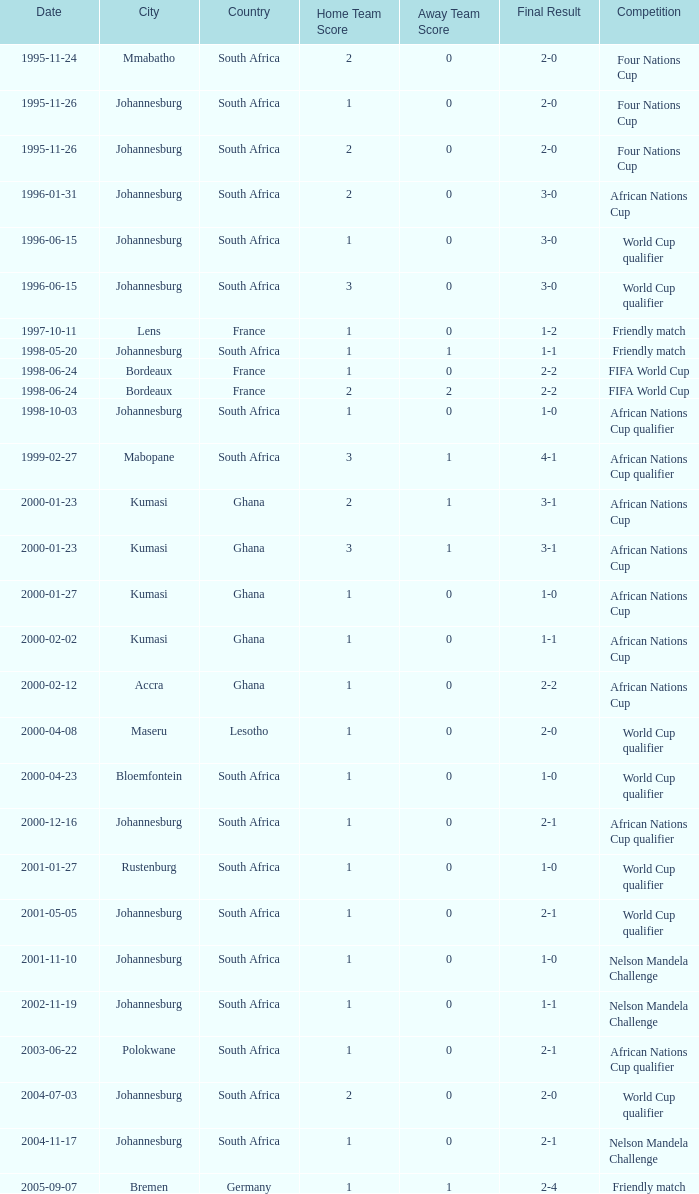What is the Venue of the Competition on 2001-05-05? Johannesburg , South Africa. 